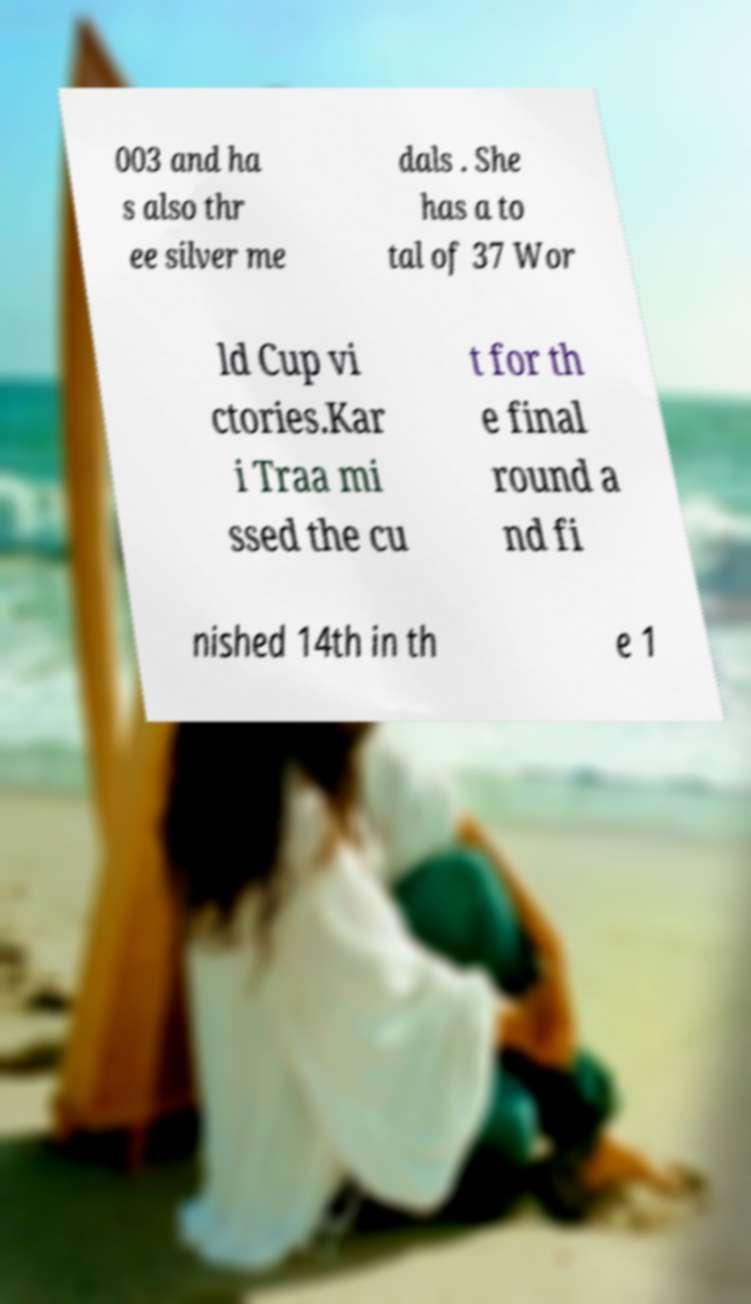Could you extract and type out the text from this image? 003 and ha s also thr ee silver me dals . She has a to tal of 37 Wor ld Cup vi ctories.Kar i Traa mi ssed the cu t for th e final round a nd fi nished 14th in th e 1 